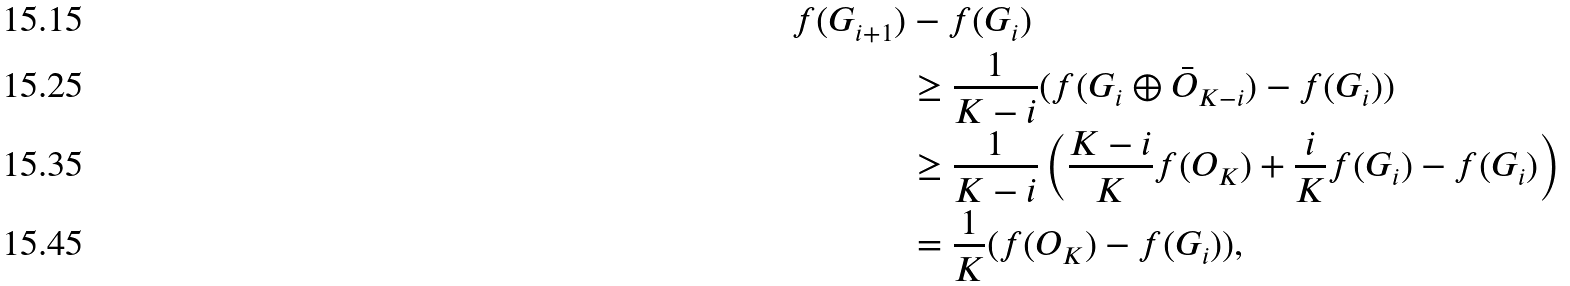<formula> <loc_0><loc_0><loc_500><loc_500>f ( G _ { i + 1 } ) & - f ( G _ { i } ) \\ & \geq \frac { 1 } { K - i } ( f ( G _ { i } \oplus \bar { O } _ { K - i } ) - f ( G _ { i } ) ) \\ & \geq \frac { 1 } { K - i } \left ( \frac { K - i } { K } f ( O _ { K } ) + \frac { i } { K } f ( G _ { i } ) - f ( G _ { i } ) \right ) \\ & = \frac { 1 } { K } ( f ( O _ { K } ) - f ( G _ { i } ) ) ,</formula> 